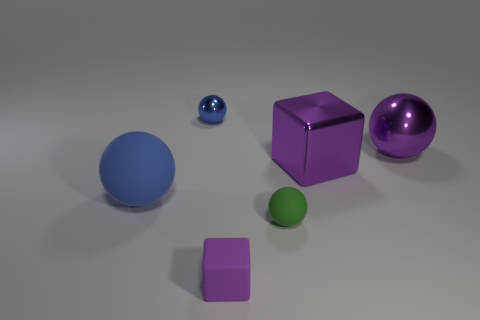Add 2 tiny blue blocks. How many objects exist? 8 Subtract all spheres. How many objects are left? 2 Add 3 blocks. How many blocks are left? 5 Add 1 yellow matte objects. How many yellow matte objects exist? 1 Subtract 1 purple spheres. How many objects are left? 5 Subtract all spheres. Subtract all large rubber things. How many objects are left? 1 